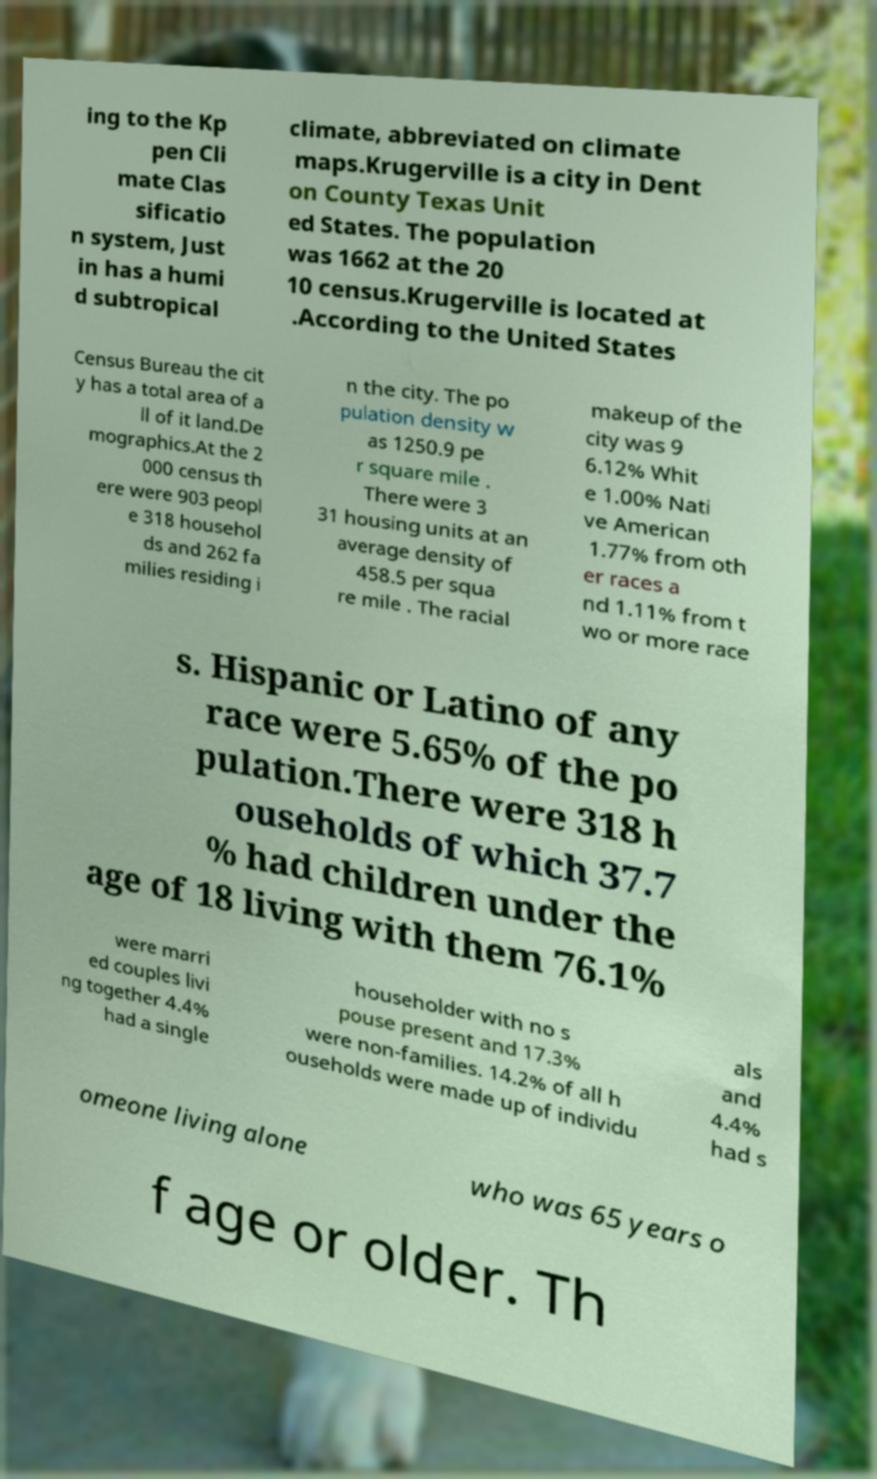I need the written content from this picture converted into text. Can you do that? ing to the Kp pen Cli mate Clas sificatio n system, Just in has a humi d subtropical climate, abbreviated on climate maps.Krugerville is a city in Dent on County Texas Unit ed States. The population was 1662 at the 20 10 census.Krugerville is located at .According to the United States Census Bureau the cit y has a total area of a ll of it land.De mographics.At the 2 000 census th ere were 903 peopl e 318 househol ds and 262 fa milies residing i n the city. The po pulation density w as 1250.9 pe r square mile . There were 3 31 housing units at an average density of 458.5 per squa re mile . The racial makeup of the city was 9 6.12% Whit e 1.00% Nati ve American 1.77% from oth er races a nd 1.11% from t wo or more race s. Hispanic or Latino of any race were 5.65% of the po pulation.There were 318 h ouseholds of which 37.7 % had children under the age of 18 living with them 76.1% were marri ed couples livi ng together 4.4% had a single householder with no s pouse present and 17.3% were non-families. 14.2% of all h ouseholds were made up of individu als and 4.4% had s omeone living alone who was 65 years o f age or older. Th 